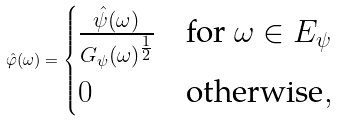Convert formula to latex. <formula><loc_0><loc_0><loc_500><loc_500>\hat { \varphi } ( \omega ) = \begin{cases} \frac { \hat { \psi } ( \omega ) } { G _ { \psi } ( \omega ) ^ { \frac { 1 } { 2 } } } & \text {for } \omega \in E _ { \psi } \\ 0 & \text {otherwise} , \end{cases}</formula> 